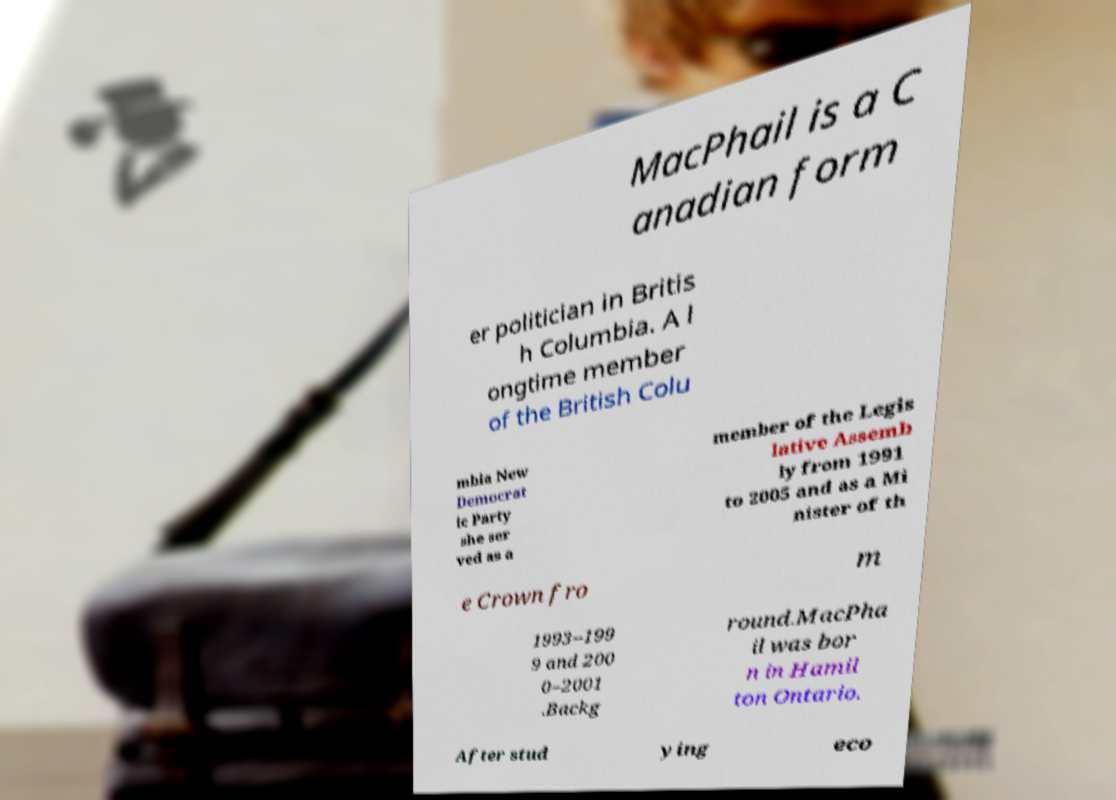What messages or text are displayed in this image? I need them in a readable, typed format. MacPhail is a C anadian form er politician in Britis h Columbia. A l ongtime member of the British Colu mbia New Democrat ic Party she ser ved as a member of the Legis lative Assemb ly from 1991 to 2005 and as a Mi nister of th e Crown fro m 1993–199 9 and 200 0–2001 .Backg round.MacPha il was bor n in Hamil ton Ontario. After stud ying eco 